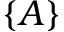<formula> <loc_0><loc_0><loc_500><loc_500>\{ A \}</formula> 